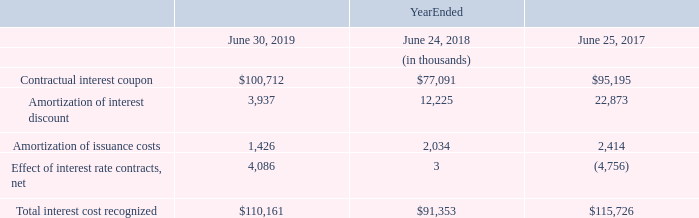Interest Cost
The following table presents the amount of interest cost recognized relating to both the contractual interest coupon and amortization of the debt discount, issuance costs, and effective portion of interest rate contracts with respect to the Senior Notes, convertible notes, the term loan agreement, commercial paper, and the revolving credit facility during the fiscal years ended June 30, 2019, June 24, 2018, and June 25, 2017.
The increase in interest expense during the 12 months ended June 30, 2019, is primarily the result of the issuance of $2.5 billion of Senior Notes in March 2019.
What is the cause of the increase in interest expense during the 12 months ended June 30, 2019? The issuance of $2.5 billion of senior notes in march 2019. What is total interest cost recognised in 2019?
Answer scale should be: thousand. $110,161. What is the contractual interest coupon in 2018?
Answer scale should be: thousand. $77,091. What is the percentage change in the Amortization of interest discount from 2018 to 2019?
Answer scale should be: percent. (3,937-12,225)/12,225
Answer: -67.8. What is the percentage change in the amortization of issuance costs from 2018 to 2019?
Answer scale should be: percent. (1,426-2,034)/2,034
Answer: -29.89. What is the percentage change in the total interest cost recognised from 2018 to 2019?
Answer scale should be: percent. (110,161-91,353)/91,353
Answer: 20.59. 